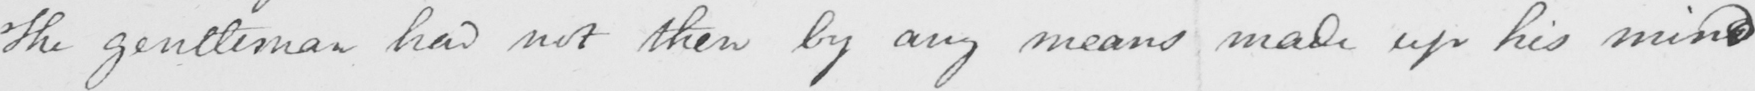What does this handwritten line say? The gentleman had not then by any means made up his mind 